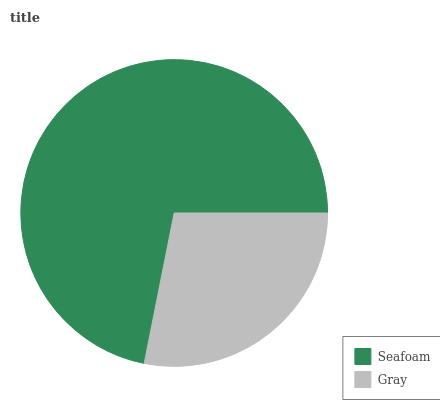Is Gray the minimum?
Answer yes or no. Yes. Is Seafoam the maximum?
Answer yes or no. Yes. Is Gray the maximum?
Answer yes or no. No. Is Seafoam greater than Gray?
Answer yes or no. Yes. Is Gray less than Seafoam?
Answer yes or no. Yes. Is Gray greater than Seafoam?
Answer yes or no. No. Is Seafoam less than Gray?
Answer yes or no. No. Is Seafoam the high median?
Answer yes or no. Yes. Is Gray the low median?
Answer yes or no. Yes. Is Gray the high median?
Answer yes or no. No. Is Seafoam the low median?
Answer yes or no. No. 